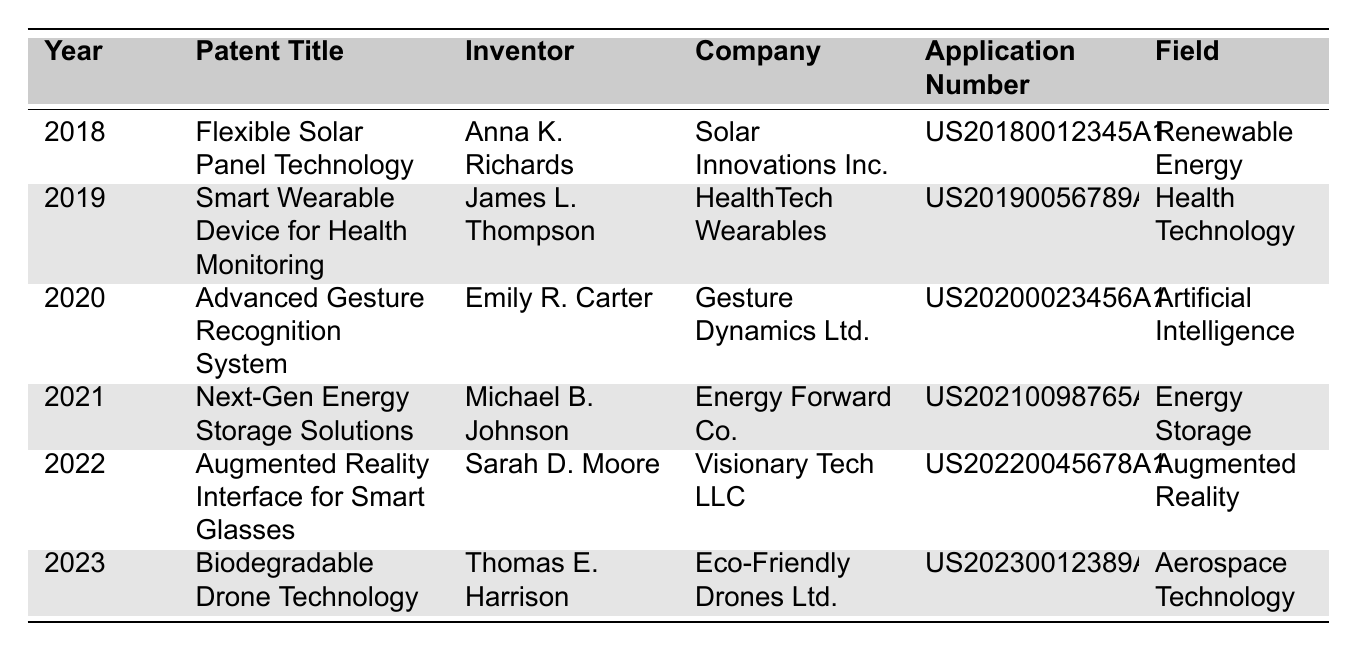What patent was filed in 2020? The table shows that the patent title listed for the year 2020 is "Advanced Gesture Recognition System."
Answer: Advanced Gesture Recognition System Who invented the "Smart Wearable Device for Health Monitoring"? By checking the row for the 2019 patent title "Smart Wearable Device for Health Monitoring," the inventor is identified as James L. Thompson.
Answer: James L. Thompson In what year was the "Augmented Reality Interface for Smart Glasses" patented? The table indicates that the patent for the "Augmented Reality Interface for Smart Glasses" was filed in 2022.
Answer: 2022 How many patents are listed in the table for the year 2021? There is one entry for the year 2021, which is "Next-Gen Energy Storage Solutions," meaning there is only one patent listed for that year.
Answer: 1 Which field has the most patents filed from 2018 to 2023? Each field listed in the table has only one patent, so no field has more patents than others; they are all equal.
Answer: None (all equal) What is the application number for the "Biodegradable Drone Technology"? The table specifies that the application number for the "Biodegradable Drone Technology" patent filed in 2023 is "US20230012389A1."
Answer: US20230012389A1 Is "Renewable Energy" the only field that has a patent filed in 2018? Reviewing the table, "Renewable Energy" is the only patent field listed for 2018, making the statement true.
Answer: Yes Which company is associated with the "Advanced Gesture Recognition System"? The company listed alongside the "Advanced Gesture Recognition System" patent from 2020 is "Gesture Dynamics Ltd."
Answer: Gesture Dynamics Ltd Are there any patents related to "Health Technology" filed in 2023? The table shows that the only patent for 2023 is related to "Aerospace Technology," confirming no patents related to "Health Technology" were filed in that year.
Answer: No What is the total number of unique inventors mentioned in the table? The inventors listed are Anna K. Richards, James L. Thompson, Emily R. Carter, Michael B. Johnson, Sarah D. Moore, and Thomas E. Harrison, totaling six unique inventors.
Answer: 6 Which patent relates to Augmented Reality? The "Augmented Reality Interface for Smart Glasses" patent listed in 2022 relates to Augmented Reality.
Answer: Augmented Reality Interface for Smart Glasses 